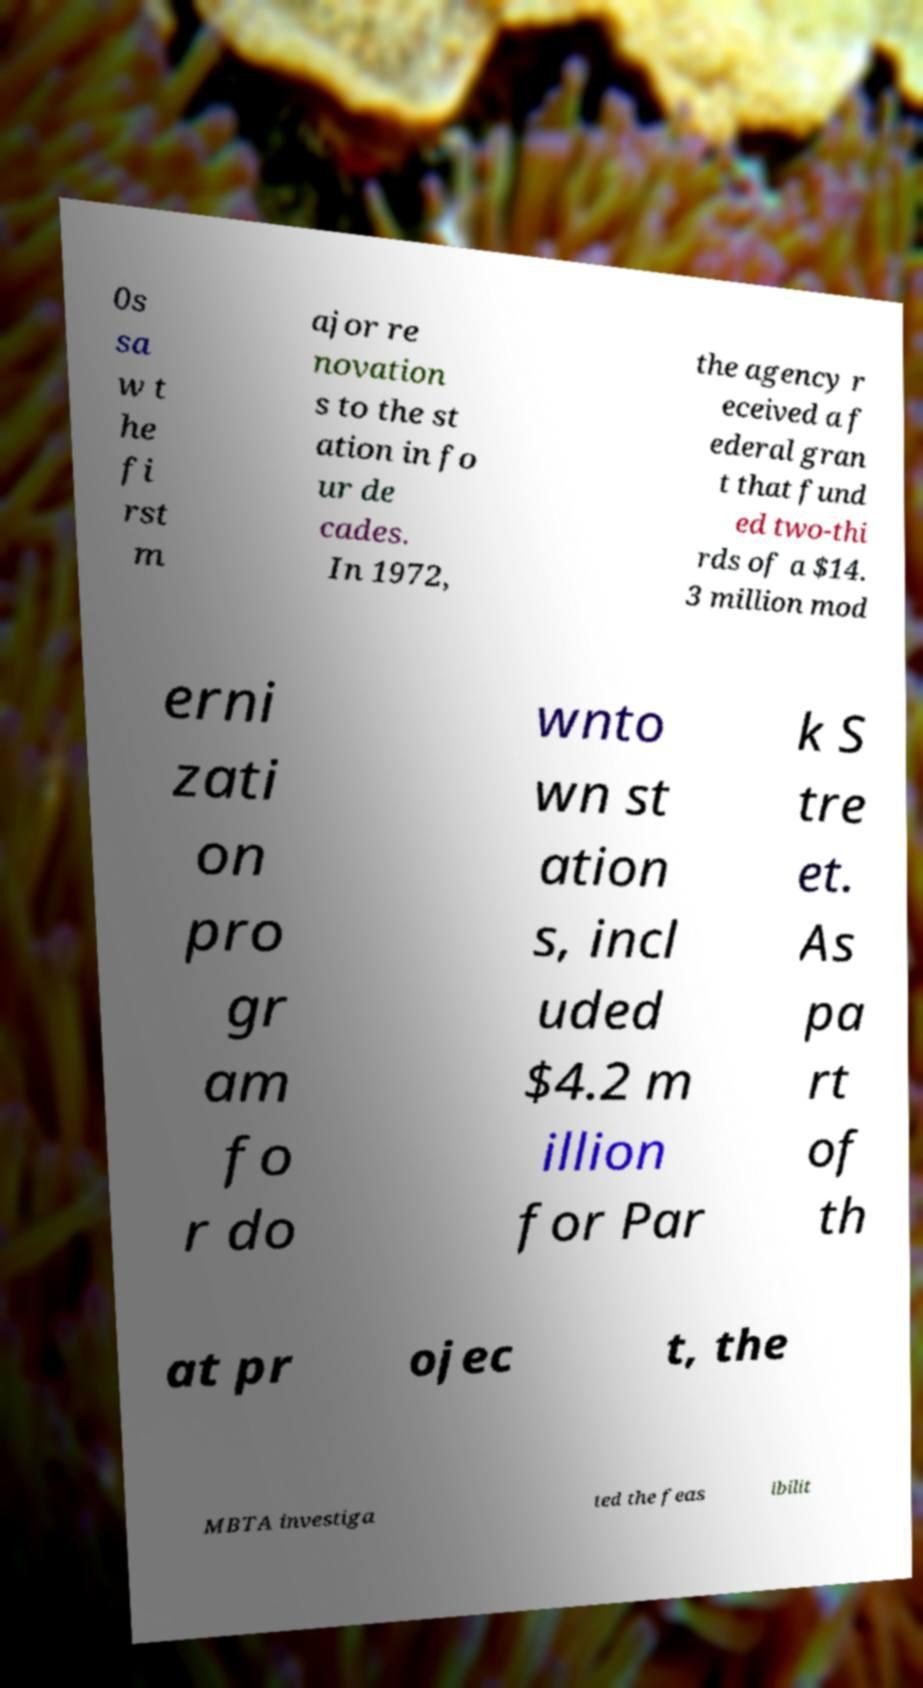I need the written content from this picture converted into text. Can you do that? 0s sa w t he fi rst m ajor re novation s to the st ation in fo ur de cades. In 1972, the agency r eceived a f ederal gran t that fund ed two-thi rds of a $14. 3 million mod erni zati on pro gr am fo r do wnto wn st ation s, incl uded $4.2 m illion for Par k S tre et. As pa rt of th at pr ojec t, the MBTA investiga ted the feas ibilit 